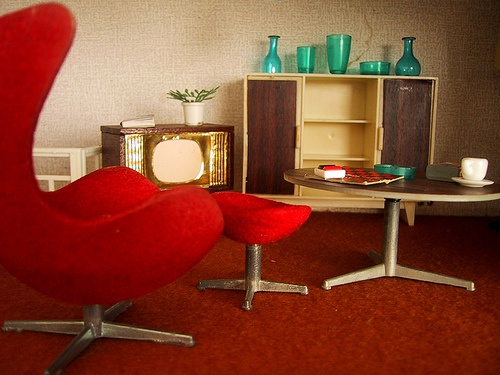Describe the objects in this image and their specific colors. I can see chair in tan, maroon, brown, and black tones, dining table in tan, maroon, and black tones, tv in tan, maroon, olive, and ivory tones, chair in tan, maroon, and red tones, and potted plant in tan, beige, and olive tones in this image. 